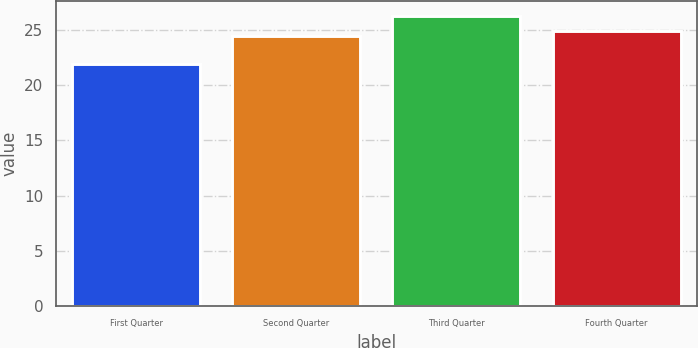Convert chart to OTSL. <chart><loc_0><loc_0><loc_500><loc_500><bar_chart><fcel>First Quarter<fcel>Second Quarter<fcel>Third Quarter<fcel>Fourth Quarter<nl><fcel>21.88<fcel>24.42<fcel>26.26<fcel>24.86<nl></chart> 